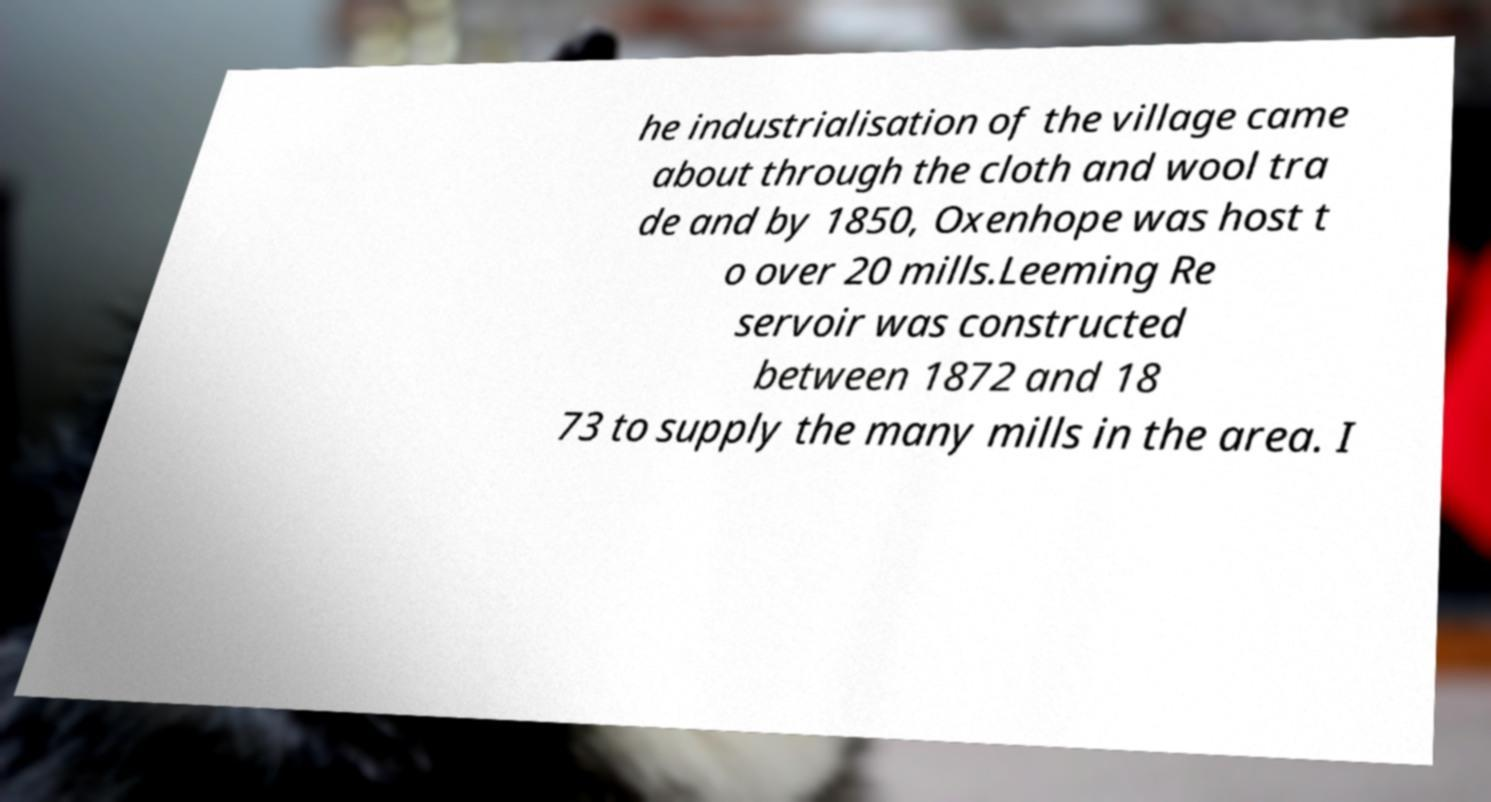There's text embedded in this image that I need extracted. Can you transcribe it verbatim? he industrialisation of the village came about through the cloth and wool tra de and by 1850, Oxenhope was host t o over 20 mills.Leeming Re servoir was constructed between 1872 and 18 73 to supply the many mills in the area. I 